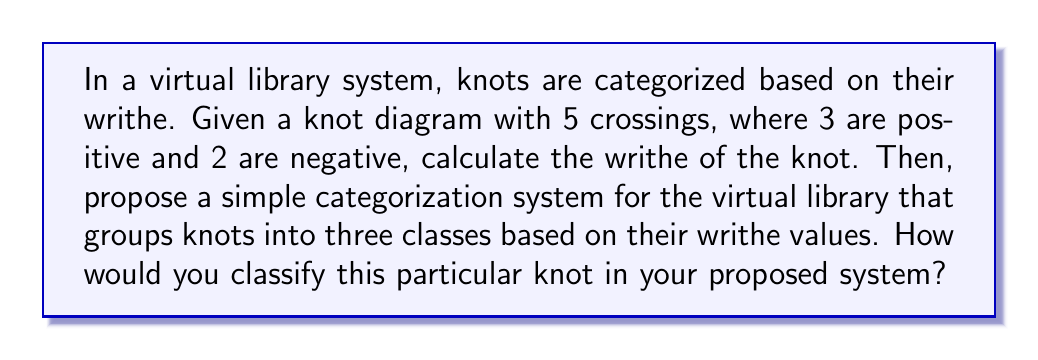Can you answer this question? Let's approach this step-by-step:

1. Calculate the writhe:
   The writhe of a knot is calculated as the sum of the signs of all crossings in a knot diagram.
   $$\text{Writhe} = \sum \text{sign(crossings)}$$
   In this case:
   $$\text{Writhe} = (+1) + (+1) + (+1) + (-1) + (-1) = +1$$

2. Propose a categorization system:
   Let's create a simple system with three categories based on writhe values:
   - Negative Writhe: $w < -1$
   - Neutral Writhe: $-1 \leq w \leq 1$
   - Positive Writhe: $w > 1$

3. Classify the given knot:
   The calculated writhe is +1, which falls into the "Neutral Writhe" category.

This system allows for a basic organization of knots in the virtual library, providing a quick way to group similar knots together. It's particularly useful for a librarian managing a digital collection, as it offers a straightforward method for categorization and retrieval.
Answer: Writhe: +1; Classification: Neutral Writhe 